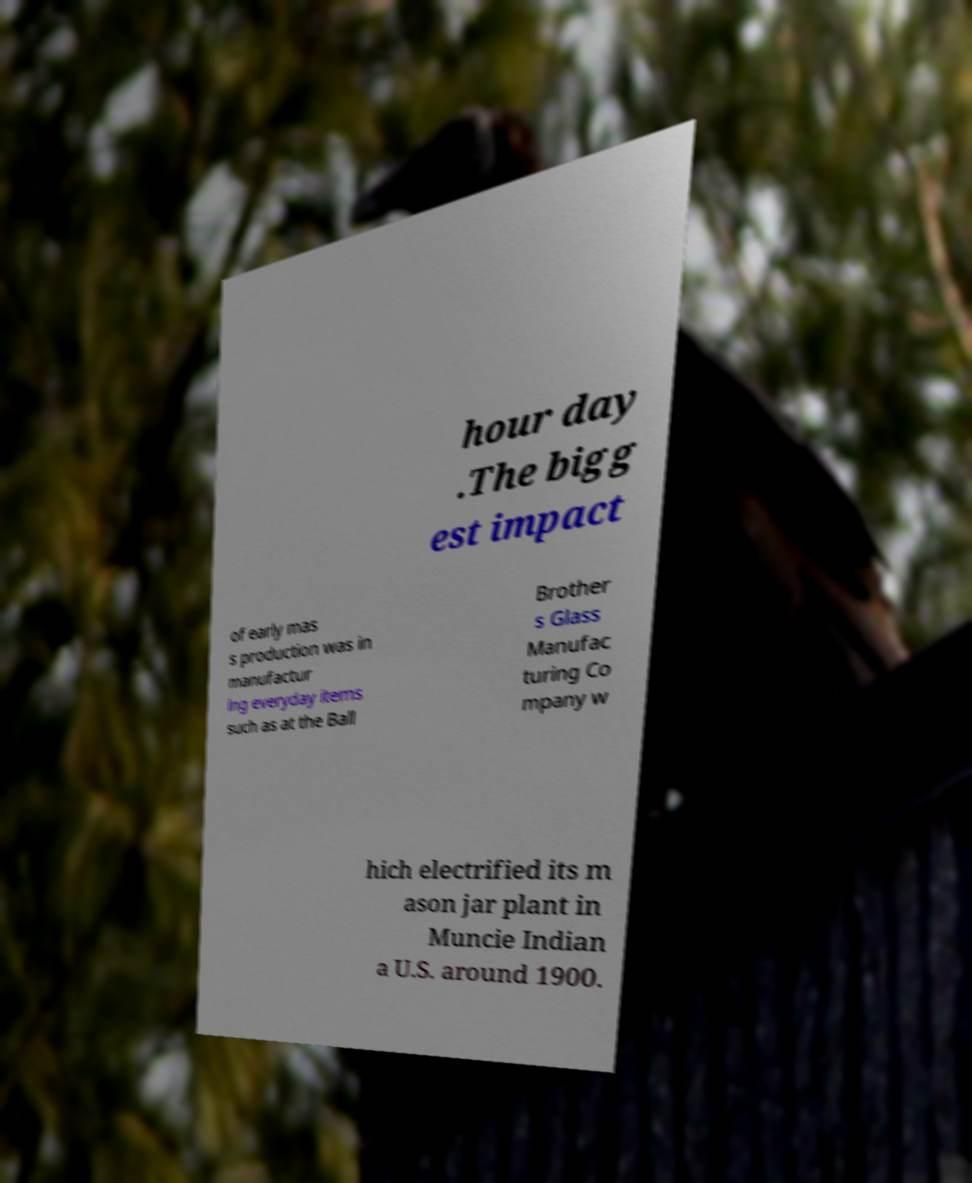Could you assist in decoding the text presented in this image and type it out clearly? hour day .The bigg est impact of early mas s production was in manufactur ing everyday items such as at the Ball Brother s Glass Manufac turing Co mpany w hich electrified its m ason jar plant in Muncie Indian a U.S. around 1900. 